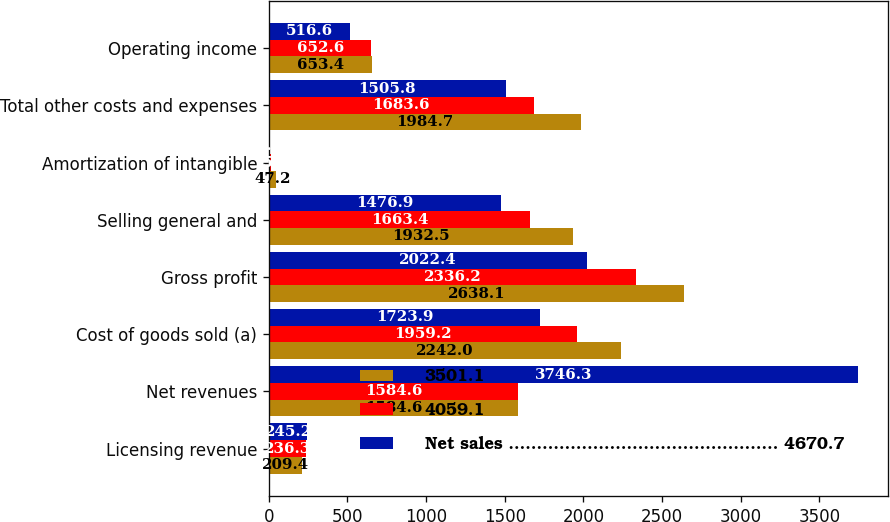<chart> <loc_0><loc_0><loc_500><loc_500><stacked_bar_chart><ecel><fcel>Licensing revenue<fcel>Net revenues<fcel>Cost of goods sold (a)<fcel>Gross profit<fcel>Selling general and<fcel>Amortization of intangible<fcel>Total other costs and expenses<fcel>Operating income<nl><fcel>3501.1<fcel>209.4<fcel>1584.6<fcel>2242<fcel>2638.1<fcel>1932.5<fcel>47.2<fcel>1984.7<fcel>653.4<nl><fcel>4059.1<fcel>236.3<fcel>1584.6<fcel>1959.2<fcel>2336.2<fcel>1663.4<fcel>15.6<fcel>1683.6<fcel>652.6<nl><fcel>Net sales ................................................ 4670.7<fcel>245.2<fcel>3746.3<fcel>1723.9<fcel>2022.4<fcel>1476.9<fcel>9.1<fcel>1505.8<fcel>516.6<nl></chart> 